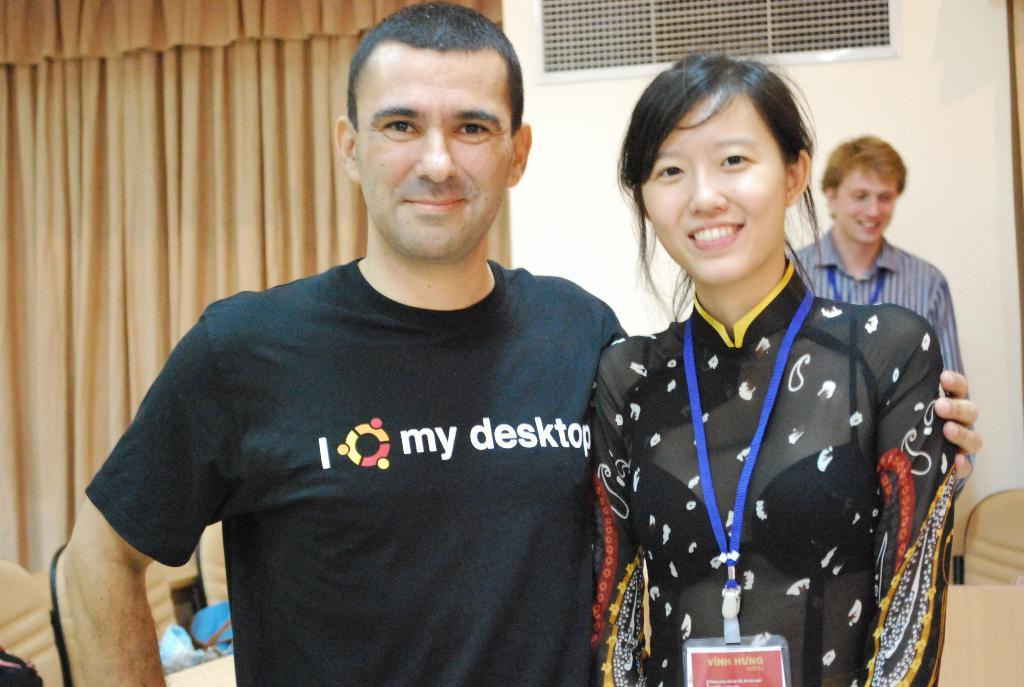Provide a one-sentence caption for the provided image. Man wearing a shirt which says I my desktop posing with a woman. 